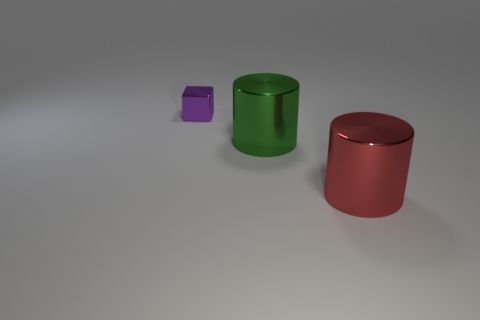What is the color of the thing that is on the left side of the large green shiny thing?
Ensure brevity in your answer.  Purple. What number of objects are either purple shiny cubes or purple shiny cubes left of the large red object?
Offer a terse response. 1. There is a large object that is left of the large red cylinder; what shape is it?
Your answer should be compact. Cylinder. There is a thing that is in front of the green shiny cylinder; is its size the same as the green shiny thing?
Ensure brevity in your answer.  Yes. Is there a object that is left of the cylinder that is left of the red metal thing?
Provide a succinct answer. Yes. Are there any small purple things made of the same material as the tiny cube?
Offer a very short reply. No. What is the material of the thing behind the large shiny cylinder to the left of the big red shiny cylinder?
Your answer should be very brief. Metal. There is a thing that is left of the big red shiny object and in front of the purple block; what material is it made of?
Ensure brevity in your answer.  Metal. Are there the same number of large green metallic objects left of the red object and purple metallic cylinders?
Provide a short and direct response. No. What number of other shiny things are the same shape as the big red object?
Provide a succinct answer. 1. 